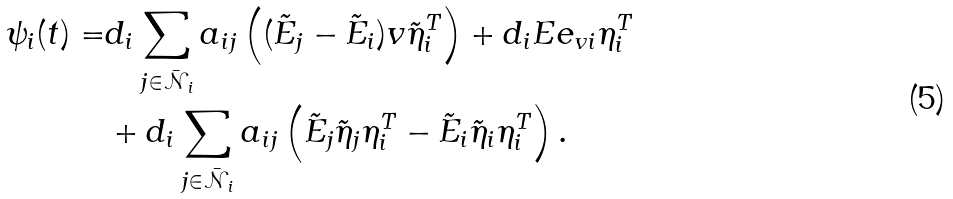Convert formula to latex. <formula><loc_0><loc_0><loc_500><loc_500>\psi _ { i } ( t ) = & d _ { i } \sum _ { j \in \mathcal { \bar { N } } _ { i } } a _ { i j } \left ( ( \tilde { E } _ { j } - \tilde { E } _ { i } ) v \tilde { \eta } _ { i } ^ { T } \right ) + d _ { i } E e _ { v i } \eta _ { i } ^ { T } \\ & + d _ { i } \sum _ { j \in \mathcal { \bar { N } } _ { i } } a _ { i j } \left ( \tilde { E } _ { j } \tilde { \eta } _ { j } \eta _ { i } ^ { T } - \tilde { E } _ { i } \tilde { \eta } _ { i } \eta _ { i } ^ { T } \right ) .</formula> 